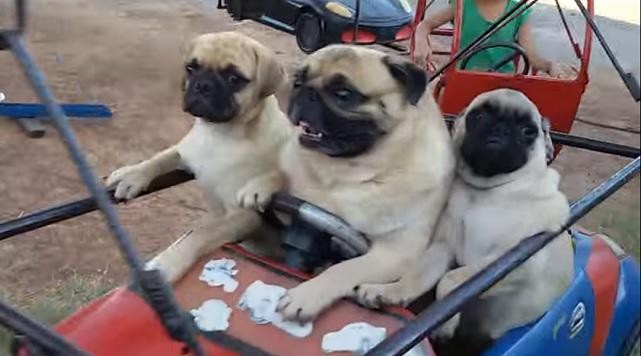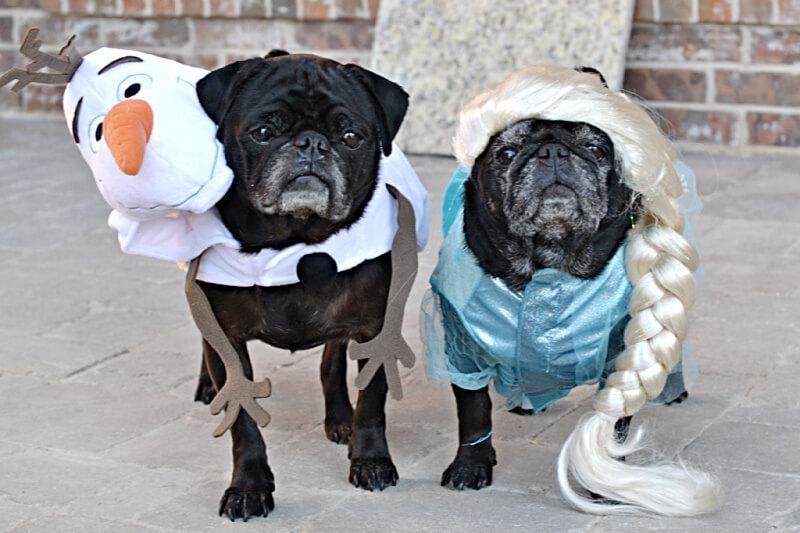The first image is the image on the left, the second image is the image on the right. Assess this claim about the two images: "Three beige pugs with dark muzzles are sitting in a row inside a red and blue car, and the middle dog has one paw on the steering wheel.". Correct or not? Answer yes or no. Yes. The first image is the image on the left, the second image is the image on the right. Given the left and right images, does the statement "Some dogs are riding a carnival ride." hold true? Answer yes or no. Yes. 